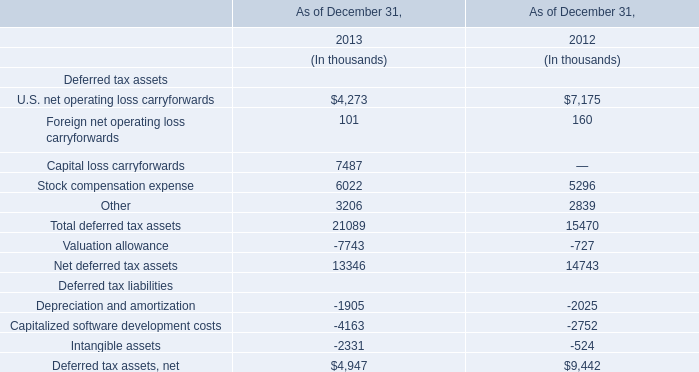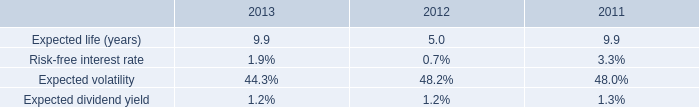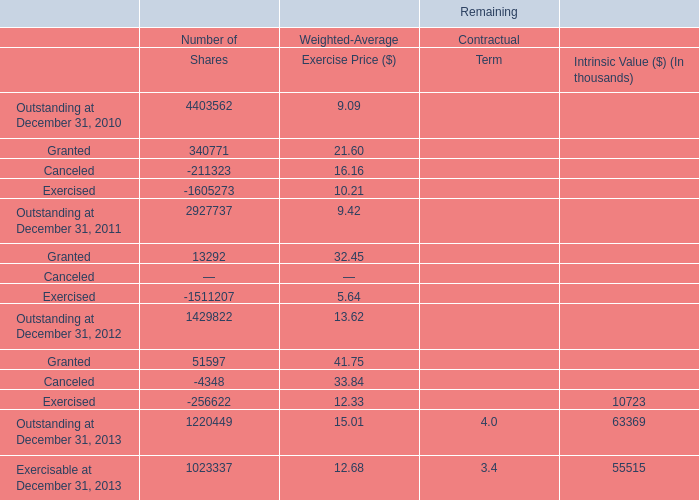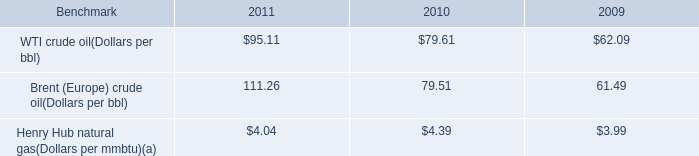What was the total amount of Granted and Canceled in Shares ? 
Computations: (340771 - 211323)
Answer: 129448.0. 